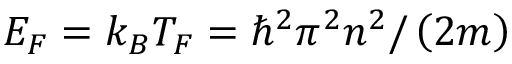<formula> <loc_0><loc_0><loc_500><loc_500>E _ { F } = k _ { B } T _ { F } = \hbar { ^ } { 2 } \pi ^ { 2 } n ^ { 2 } / \left ( 2 m \right )</formula> 